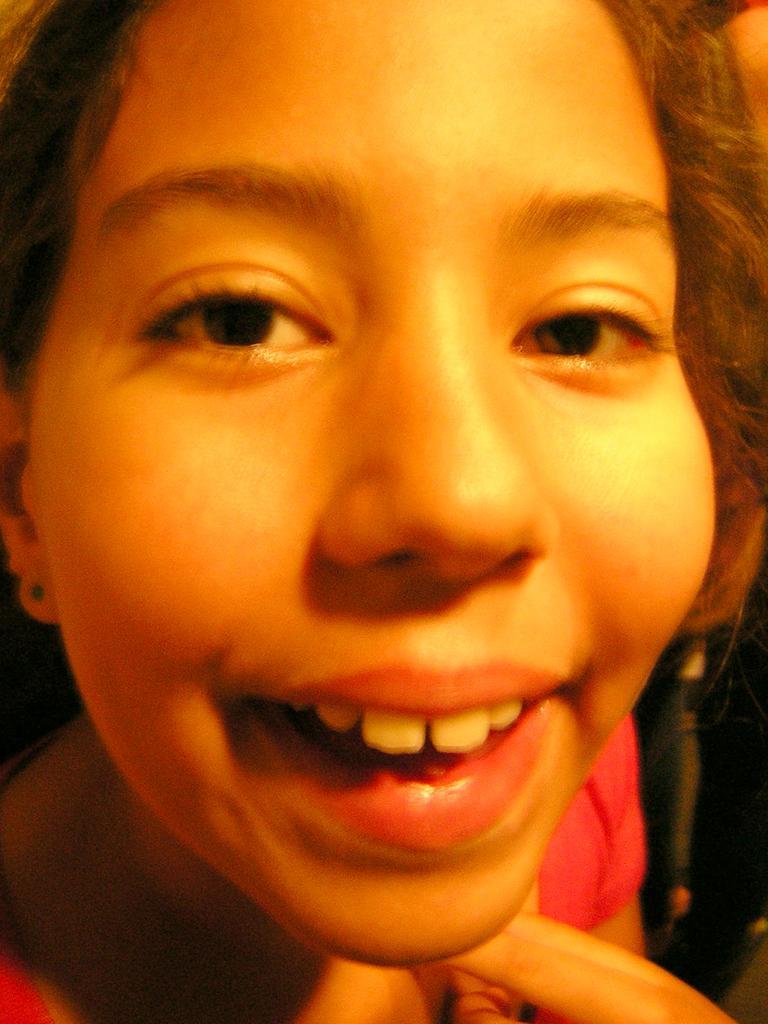Can you describe this image briefly? There is a zoom-in picture of a face of girl as we can see in the middle of this image. 